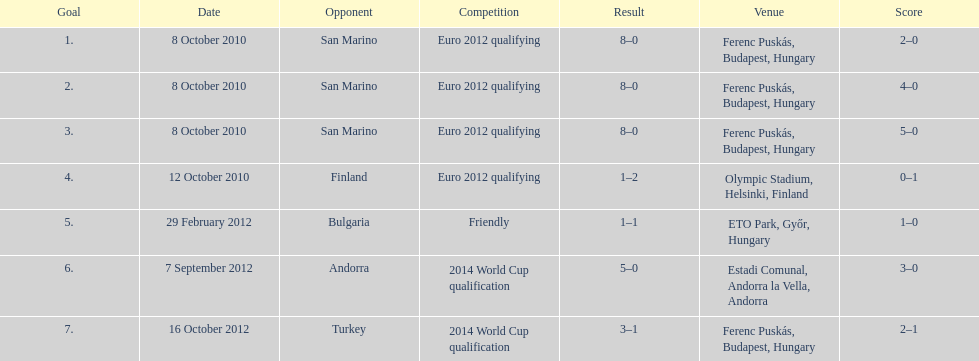Szalai scored all but one of his international goals in either euro 2012 qualifying or what other level of play? 2014 World Cup qualification. 